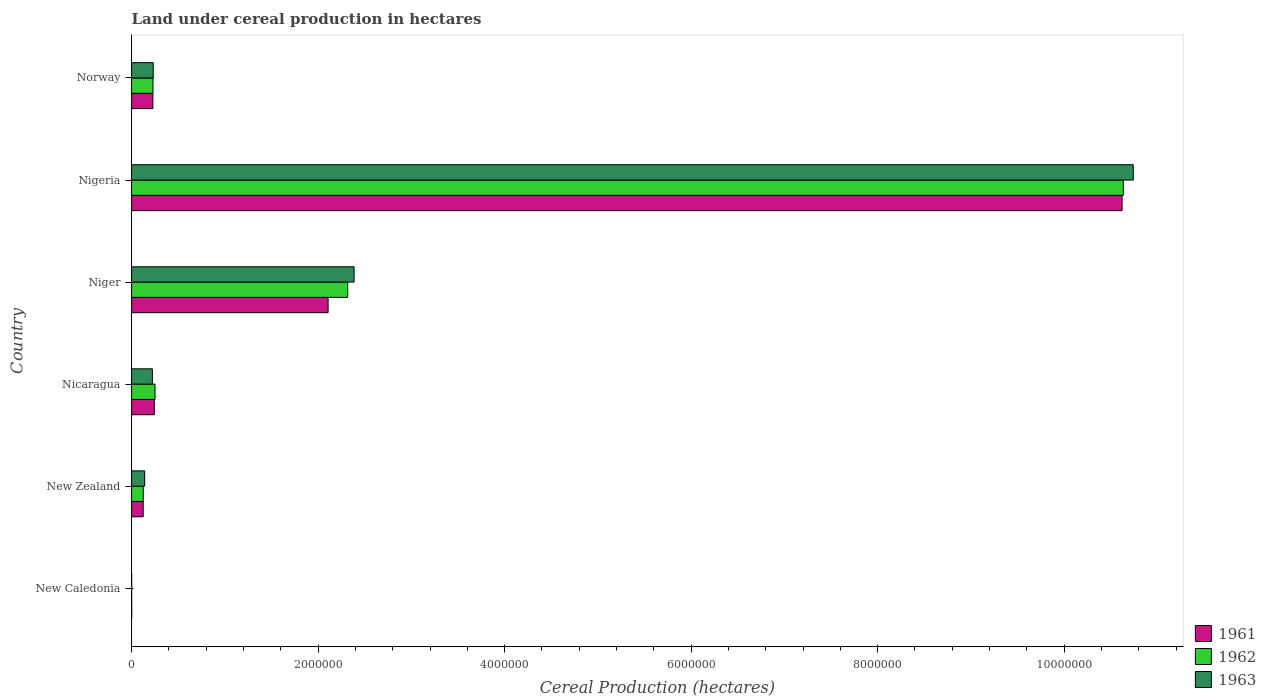How many groups of bars are there?
Provide a succinct answer. 6. How many bars are there on the 1st tick from the bottom?
Keep it short and to the point. 3. What is the label of the 3rd group of bars from the top?
Offer a very short reply. Niger. What is the land under cereal production in 1962 in New Caledonia?
Give a very brief answer. 950. Across all countries, what is the maximum land under cereal production in 1963?
Offer a terse response. 1.07e+07. Across all countries, what is the minimum land under cereal production in 1962?
Your answer should be very brief. 950. In which country was the land under cereal production in 1962 maximum?
Ensure brevity in your answer.  Nigeria. In which country was the land under cereal production in 1962 minimum?
Make the answer very short. New Caledonia. What is the total land under cereal production in 1963 in the graph?
Offer a terse response. 1.37e+07. What is the difference between the land under cereal production in 1962 in Nicaragua and that in Niger?
Provide a succinct answer. -2.07e+06. What is the difference between the land under cereal production in 1963 in Norway and the land under cereal production in 1961 in New Caledonia?
Your answer should be compact. 2.31e+05. What is the average land under cereal production in 1963 per country?
Your answer should be compact. 2.29e+06. What is the ratio of the land under cereal production in 1963 in New Zealand to that in Nigeria?
Offer a terse response. 0.01. Is the land under cereal production in 1962 in New Zealand less than that in Niger?
Offer a terse response. Yes. What is the difference between the highest and the second highest land under cereal production in 1962?
Offer a terse response. 8.32e+06. What is the difference between the highest and the lowest land under cereal production in 1962?
Offer a terse response. 1.06e+07. Is the sum of the land under cereal production in 1962 in New Zealand and Nigeria greater than the maximum land under cereal production in 1963 across all countries?
Your answer should be compact. Yes. Is it the case that in every country, the sum of the land under cereal production in 1963 and land under cereal production in 1962 is greater than the land under cereal production in 1961?
Ensure brevity in your answer.  Yes. How many bars are there?
Ensure brevity in your answer.  18. Are the values on the major ticks of X-axis written in scientific E-notation?
Your answer should be very brief. No. Does the graph contain grids?
Provide a succinct answer. No. Where does the legend appear in the graph?
Offer a very short reply. Bottom right. What is the title of the graph?
Give a very brief answer. Land under cereal production in hectares. What is the label or title of the X-axis?
Your answer should be compact. Cereal Production (hectares). What is the label or title of the Y-axis?
Provide a short and direct response. Country. What is the Cereal Production (hectares) of 1961 in New Caledonia?
Provide a short and direct response. 1050. What is the Cereal Production (hectares) of 1962 in New Caledonia?
Your response must be concise. 950. What is the Cereal Production (hectares) in 1963 in New Caledonia?
Your answer should be very brief. 900. What is the Cereal Production (hectares) in 1961 in New Zealand?
Offer a very short reply. 1.24e+05. What is the Cereal Production (hectares) in 1962 in New Zealand?
Your answer should be compact. 1.26e+05. What is the Cereal Production (hectares) in 1963 in New Zealand?
Ensure brevity in your answer.  1.40e+05. What is the Cereal Production (hectares) of 1961 in Nicaragua?
Give a very brief answer. 2.44e+05. What is the Cereal Production (hectares) of 1962 in Nicaragua?
Make the answer very short. 2.52e+05. What is the Cereal Production (hectares) of 1963 in Nicaragua?
Make the answer very short. 2.23e+05. What is the Cereal Production (hectares) of 1961 in Niger?
Offer a very short reply. 2.11e+06. What is the Cereal Production (hectares) of 1962 in Niger?
Keep it short and to the point. 2.32e+06. What is the Cereal Production (hectares) of 1963 in Niger?
Offer a very short reply. 2.39e+06. What is the Cereal Production (hectares) in 1961 in Nigeria?
Provide a succinct answer. 1.06e+07. What is the Cereal Production (hectares) of 1962 in Nigeria?
Provide a succinct answer. 1.06e+07. What is the Cereal Production (hectares) of 1963 in Nigeria?
Ensure brevity in your answer.  1.07e+07. What is the Cereal Production (hectares) of 1961 in Norway?
Your answer should be compact. 2.28e+05. What is the Cereal Production (hectares) of 1962 in Norway?
Offer a terse response. 2.30e+05. What is the Cereal Production (hectares) in 1963 in Norway?
Ensure brevity in your answer.  2.32e+05. Across all countries, what is the maximum Cereal Production (hectares) in 1961?
Keep it short and to the point. 1.06e+07. Across all countries, what is the maximum Cereal Production (hectares) of 1962?
Your answer should be very brief. 1.06e+07. Across all countries, what is the maximum Cereal Production (hectares) in 1963?
Offer a terse response. 1.07e+07. Across all countries, what is the minimum Cereal Production (hectares) in 1961?
Your answer should be compact. 1050. Across all countries, what is the minimum Cereal Production (hectares) of 1962?
Your response must be concise. 950. Across all countries, what is the minimum Cereal Production (hectares) of 1963?
Make the answer very short. 900. What is the total Cereal Production (hectares) in 1961 in the graph?
Your response must be concise. 1.33e+07. What is the total Cereal Production (hectares) in 1962 in the graph?
Your answer should be compact. 1.36e+07. What is the total Cereal Production (hectares) of 1963 in the graph?
Offer a terse response. 1.37e+07. What is the difference between the Cereal Production (hectares) in 1961 in New Caledonia and that in New Zealand?
Your answer should be compact. -1.23e+05. What is the difference between the Cereal Production (hectares) of 1962 in New Caledonia and that in New Zealand?
Provide a succinct answer. -1.25e+05. What is the difference between the Cereal Production (hectares) in 1963 in New Caledonia and that in New Zealand?
Give a very brief answer. -1.39e+05. What is the difference between the Cereal Production (hectares) in 1961 in New Caledonia and that in Nicaragua?
Provide a short and direct response. -2.42e+05. What is the difference between the Cereal Production (hectares) of 1962 in New Caledonia and that in Nicaragua?
Your answer should be compact. -2.51e+05. What is the difference between the Cereal Production (hectares) of 1963 in New Caledonia and that in Nicaragua?
Your answer should be very brief. -2.22e+05. What is the difference between the Cereal Production (hectares) of 1961 in New Caledonia and that in Niger?
Make the answer very short. -2.11e+06. What is the difference between the Cereal Production (hectares) of 1962 in New Caledonia and that in Niger?
Your response must be concise. -2.32e+06. What is the difference between the Cereal Production (hectares) of 1963 in New Caledonia and that in Niger?
Your answer should be very brief. -2.39e+06. What is the difference between the Cereal Production (hectares) in 1961 in New Caledonia and that in Nigeria?
Give a very brief answer. -1.06e+07. What is the difference between the Cereal Production (hectares) in 1962 in New Caledonia and that in Nigeria?
Keep it short and to the point. -1.06e+07. What is the difference between the Cereal Production (hectares) of 1963 in New Caledonia and that in Nigeria?
Give a very brief answer. -1.07e+07. What is the difference between the Cereal Production (hectares) of 1961 in New Caledonia and that in Norway?
Your response must be concise. -2.27e+05. What is the difference between the Cereal Production (hectares) in 1962 in New Caledonia and that in Norway?
Offer a very short reply. -2.29e+05. What is the difference between the Cereal Production (hectares) of 1963 in New Caledonia and that in Norway?
Your response must be concise. -2.31e+05. What is the difference between the Cereal Production (hectares) of 1961 in New Zealand and that in Nicaragua?
Give a very brief answer. -1.19e+05. What is the difference between the Cereal Production (hectares) of 1962 in New Zealand and that in Nicaragua?
Make the answer very short. -1.26e+05. What is the difference between the Cereal Production (hectares) of 1963 in New Zealand and that in Nicaragua?
Your answer should be very brief. -8.27e+04. What is the difference between the Cereal Production (hectares) in 1961 in New Zealand and that in Niger?
Your response must be concise. -1.98e+06. What is the difference between the Cereal Production (hectares) of 1962 in New Zealand and that in Niger?
Your answer should be very brief. -2.19e+06. What is the difference between the Cereal Production (hectares) of 1963 in New Zealand and that in Niger?
Provide a short and direct response. -2.25e+06. What is the difference between the Cereal Production (hectares) in 1961 in New Zealand and that in Nigeria?
Keep it short and to the point. -1.05e+07. What is the difference between the Cereal Production (hectares) of 1962 in New Zealand and that in Nigeria?
Offer a very short reply. -1.05e+07. What is the difference between the Cereal Production (hectares) in 1963 in New Zealand and that in Nigeria?
Make the answer very short. -1.06e+07. What is the difference between the Cereal Production (hectares) of 1961 in New Zealand and that in Norway?
Your answer should be very brief. -1.04e+05. What is the difference between the Cereal Production (hectares) in 1962 in New Zealand and that in Norway?
Make the answer very short. -1.04e+05. What is the difference between the Cereal Production (hectares) of 1963 in New Zealand and that in Norway?
Your answer should be compact. -9.19e+04. What is the difference between the Cereal Production (hectares) in 1961 in Nicaragua and that in Niger?
Provide a short and direct response. -1.86e+06. What is the difference between the Cereal Production (hectares) of 1962 in Nicaragua and that in Niger?
Keep it short and to the point. -2.07e+06. What is the difference between the Cereal Production (hectares) of 1963 in Nicaragua and that in Niger?
Your answer should be compact. -2.16e+06. What is the difference between the Cereal Production (hectares) in 1961 in Nicaragua and that in Nigeria?
Your answer should be very brief. -1.04e+07. What is the difference between the Cereal Production (hectares) of 1962 in Nicaragua and that in Nigeria?
Make the answer very short. -1.04e+07. What is the difference between the Cereal Production (hectares) of 1963 in Nicaragua and that in Nigeria?
Your answer should be very brief. -1.05e+07. What is the difference between the Cereal Production (hectares) in 1961 in Nicaragua and that in Norway?
Your answer should be compact. 1.54e+04. What is the difference between the Cereal Production (hectares) in 1962 in Nicaragua and that in Norway?
Give a very brief answer. 2.20e+04. What is the difference between the Cereal Production (hectares) in 1963 in Nicaragua and that in Norway?
Provide a succinct answer. -9143. What is the difference between the Cereal Production (hectares) in 1961 in Niger and that in Nigeria?
Your answer should be very brief. -8.51e+06. What is the difference between the Cereal Production (hectares) in 1962 in Niger and that in Nigeria?
Ensure brevity in your answer.  -8.32e+06. What is the difference between the Cereal Production (hectares) of 1963 in Niger and that in Nigeria?
Your response must be concise. -8.36e+06. What is the difference between the Cereal Production (hectares) in 1961 in Niger and that in Norway?
Provide a short and direct response. 1.88e+06. What is the difference between the Cereal Production (hectares) in 1962 in Niger and that in Norway?
Your answer should be compact. 2.09e+06. What is the difference between the Cereal Production (hectares) in 1963 in Niger and that in Norway?
Your answer should be compact. 2.15e+06. What is the difference between the Cereal Production (hectares) in 1961 in Nigeria and that in Norway?
Your response must be concise. 1.04e+07. What is the difference between the Cereal Production (hectares) in 1962 in Nigeria and that in Norway?
Provide a succinct answer. 1.04e+07. What is the difference between the Cereal Production (hectares) of 1963 in Nigeria and that in Norway?
Offer a terse response. 1.05e+07. What is the difference between the Cereal Production (hectares) in 1961 in New Caledonia and the Cereal Production (hectares) in 1962 in New Zealand?
Offer a terse response. -1.25e+05. What is the difference between the Cereal Production (hectares) of 1961 in New Caledonia and the Cereal Production (hectares) of 1963 in New Zealand?
Make the answer very short. -1.39e+05. What is the difference between the Cereal Production (hectares) of 1962 in New Caledonia and the Cereal Production (hectares) of 1963 in New Zealand?
Your answer should be very brief. -1.39e+05. What is the difference between the Cereal Production (hectares) in 1961 in New Caledonia and the Cereal Production (hectares) in 1962 in Nicaragua?
Provide a succinct answer. -2.50e+05. What is the difference between the Cereal Production (hectares) in 1961 in New Caledonia and the Cereal Production (hectares) in 1963 in Nicaragua?
Your response must be concise. -2.22e+05. What is the difference between the Cereal Production (hectares) in 1962 in New Caledonia and the Cereal Production (hectares) in 1963 in Nicaragua?
Provide a succinct answer. -2.22e+05. What is the difference between the Cereal Production (hectares) in 1961 in New Caledonia and the Cereal Production (hectares) in 1962 in Niger?
Provide a succinct answer. -2.32e+06. What is the difference between the Cereal Production (hectares) of 1961 in New Caledonia and the Cereal Production (hectares) of 1963 in Niger?
Your answer should be compact. -2.38e+06. What is the difference between the Cereal Production (hectares) in 1962 in New Caledonia and the Cereal Production (hectares) in 1963 in Niger?
Offer a terse response. -2.39e+06. What is the difference between the Cereal Production (hectares) of 1961 in New Caledonia and the Cereal Production (hectares) of 1962 in Nigeria?
Offer a very short reply. -1.06e+07. What is the difference between the Cereal Production (hectares) of 1961 in New Caledonia and the Cereal Production (hectares) of 1963 in Nigeria?
Offer a terse response. -1.07e+07. What is the difference between the Cereal Production (hectares) of 1962 in New Caledonia and the Cereal Production (hectares) of 1963 in Nigeria?
Offer a very short reply. -1.07e+07. What is the difference between the Cereal Production (hectares) of 1961 in New Caledonia and the Cereal Production (hectares) of 1962 in Norway?
Offer a terse response. -2.28e+05. What is the difference between the Cereal Production (hectares) in 1961 in New Caledonia and the Cereal Production (hectares) in 1963 in Norway?
Ensure brevity in your answer.  -2.31e+05. What is the difference between the Cereal Production (hectares) of 1962 in New Caledonia and the Cereal Production (hectares) of 1963 in Norway?
Provide a short and direct response. -2.31e+05. What is the difference between the Cereal Production (hectares) in 1961 in New Zealand and the Cereal Production (hectares) in 1962 in Nicaragua?
Your answer should be very brief. -1.27e+05. What is the difference between the Cereal Production (hectares) of 1961 in New Zealand and the Cereal Production (hectares) of 1963 in Nicaragua?
Keep it short and to the point. -9.87e+04. What is the difference between the Cereal Production (hectares) in 1962 in New Zealand and the Cereal Production (hectares) in 1963 in Nicaragua?
Offer a very short reply. -9.75e+04. What is the difference between the Cereal Production (hectares) in 1961 in New Zealand and the Cereal Production (hectares) in 1962 in Niger?
Ensure brevity in your answer.  -2.19e+06. What is the difference between the Cereal Production (hectares) in 1961 in New Zealand and the Cereal Production (hectares) in 1963 in Niger?
Make the answer very short. -2.26e+06. What is the difference between the Cereal Production (hectares) in 1962 in New Zealand and the Cereal Production (hectares) in 1963 in Niger?
Your answer should be compact. -2.26e+06. What is the difference between the Cereal Production (hectares) in 1961 in New Zealand and the Cereal Production (hectares) in 1962 in Nigeria?
Your answer should be very brief. -1.05e+07. What is the difference between the Cereal Production (hectares) in 1961 in New Zealand and the Cereal Production (hectares) in 1963 in Nigeria?
Your answer should be very brief. -1.06e+07. What is the difference between the Cereal Production (hectares) of 1962 in New Zealand and the Cereal Production (hectares) of 1963 in Nigeria?
Your answer should be very brief. -1.06e+07. What is the difference between the Cereal Production (hectares) in 1961 in New Zealand and the Cereal Production (hectares) in 1962 in Norway?
Offer a terse response. -1.05e+05. What is the difference between the Cereal Production (hectares) in 1961 in New Zealand and the Cereal Production (hectares) in 1963 in Norway?
Make the answer very short. -1.08e+05. What is the difference between the Cereal Production (hectares) in 1962 in New Zealand and the Cereal Production (hectares) in 1963 in Norway?
Offer a very short reply. -1.07e+05. What is the difference between the Cereal Production (hectares) of 1961 in Nicaragua and the Cereal Production (hectares) of 1962 in Niger?
Your answer should be very brief. -2.07e+06. What is the difference between the Cereal Production (hectares) of 1961 in Nicaragua and the Cereal Production (hectares) of 1963 in Niger?
Provide a short and direct response. -2.14e+06. What is the difference between the Cereal Production (hectares) in 1962 in Nicaragua and the Cereal Production (hectares) in 1963 in Niger?
Provide a succinct answer. -2.13e+06. What is the difference between the Cereal Production (hectares) of 1961 in Nicaragua and the Cereal Production (hectares) of 1962 in Nigeria?
Your answer should be very brief. -1.04e+07. What is the difference between the Cereal Production (hectares) in 1961 in Nicaragua and the Cereal Production (hectares) in 1963 in Nigeria?
Give a very brief answer. -1.05e+07. What is the difference between the Cereal Production (hectares) in 1962 in Nicaragua and the Cereal Production (hectares) in 1963 in Nigeria?
Offer a very short reply. -1.05e+07. What is the difference between the Cereal Production (hectares) of 1961 in Nicaragua and the Cereal Production (hectares) of 1962 in Norway?
Offer a very short reply. 1.40e+04. What is the difference between the Cereal Production (hectares) of 1961 in Nicaragua and the Cereal Production (hectares) of 1963 in Norway?
Offer a terse response. 1.13e+04. What is the difference between the Cereal Production (hectares) in 1962 in Nicaragua and the Cereal Production (hectares) in 1963 in Norway?
Provide a short and direct response. 1.93e+04. What is the difference between the Cereal Production (hectares) in 1961 in Niger and the Cereal Production (hectares) in 1962 in Nigeria?
Offer a terse response. -8.53e+06. What is the difference between the Cereal Production (hectares) of 1961 in Niger and the Cereal Production (hectares) of 1963 in Nigeria?
Ensure brevity in your answer.  -8.63e+06. What is the difference between the Cereal Production (hectares) in 1962 in Niger and the Cereal Production (hectares) in 1963 in Nigeria?
Make the answer very short. -8.42e+06. What is the difference between the Cereal Production (hectares) in 1961 in Niger and the Cereal Production (hectares) in 1962 in Norway?
Keep it short and to the point. 1.88e+06. What is the difference between the Cereal Production (hectares) in 1961 in Niger and the Cereal Production (hectares) in 1963 in Norway?
Your answer should be compact. 1.87e+06. What is the difference between the Cereal Production (hectares) in 1962 in Niger and the Cereal Production (hectares) in 1963 in Norway?
Give a very brief answer. 2.09e+06. What is the difference between the Cereal Production (hectares) of 1961 in Nigeria and the Cereal Production (hectares) of 1962 in Norway?
Give a very brief answer. 1.04e+07. What is the difference between the Cereal Production (hectares) in 1961 in Nigeria and the Cereal Production (hectares) in 1963 in Norway?
Offer a very short reply. 1.04e+07. What is the difference between the Cereal Production (hectares) in 1962 in Nigeria and the Cereal Production (hectares) in 1963 in Norway?
Your response must be concise. 1.04e+07. What is the average Cereal Production (hectares) in 1961 per country?
Offer a very short reply. 2.22e+06. What is the average Cereal Production (hectares) of 1962 per country?
Your response must be concise. 2.26e+06. What is the average Cereal Production (hectares) of 1963 per country?
Your answer should be compact. 2.29e+06. What is the difference between the Cereal Production (hectares) of 1961 and Cereal Production (hectares) of 1962 in New Caledonia?
Keep it short and to the point. 100. What is the difference between the Cereal Production (hectares) in 1961 and Cereal Production (hectares) in 1963 in New Caledonia?
Keep it short and to the point. 150. What is the difference between the Cereal Production (hectares) in 1961 and Cereal Production (hectares) in 1962 in New Zealand?
Keep it short and to the point. -1208. What is the difference between the Cereal Production (hectares) of 1961 and Cereal Production (hectares) of 1963 in New Zealand?
Your answer should be very brief. -1.60e+04. What is the difference between the Cereal Production (hectares) in 1962 and Cereal Production (hectares) in 1963 in New Zealand?
Your answer should be compact. -1.48e+04. What is the difference between the Cereal Production (hectares) of 1961 and Cereal Production (hectares) of 1962 in Nicaragua?
Your answer should be compact. -8000. What is the difference between the Cereal Production (hectares) of 1961 and Cereal Production (hectares) of 1963 in Nicaragua?
Provide a succinct answer. 2.04e+04. What is the difference between the Cereal Production (hectares) of 1962 and Cereal Production (hectares) of 1963 in Nicaragua?
Give a very brief answer. 2.84e+04. What is the difference between the Cereal Production (hectares) in 1961 and Cereal Production (hectares) in 1962 in Niger?
Give a very brief answer. -2.10e+05. What is the difference between the Cereal Production (hectares) of 1961 and Cereal Production (hectares) of 1963 in Niger?
Provide a succinct answer. -2.79e+05. What is the difference between the Cereal Production (hectares) in 1962 and Cereal Production (hectares) in 1963 in Niger?
Give a very brief answer. -6.85e+04. What is the difference between the Cereal Production (hectares) in 1961 and Cereal Production (hectares) in 1962 in Nigeria?
Offer a terse response. -1.30e+04. What is the difference between the Cereal Production (hectares) in 1961 and Cereal Production (hectares) in 1963 in Nigeria?
Your answer should be compact. -1.20e+05. What is the difference between the Cereal Production (hectares) of 1962 and Cereal Production (hectares) of 1963 in Nigeria?
Ensure brevity in your answer.  -1.07e+05. What is the difference between the Cereal Production (hectares) in 1961 and Cereal Production (hectares) in 1962 in Norway?
Your response must be concise. -1405. What is the difference between the Cereal Production (hectares) in 1961 and Cereal Production (hectares) in 1963 in Norway?
Provide a succinct answer. -4126. What is the difference between the Cereal Production (hectares) in 1962 and Cereal Production (hectares) in 1963 in Norway?
Give a very brief answer. -2721. What is the ratio of the Cereal Production (hectares) of 1961 in New Caledonia to that in New Zealand?
Provide a short and direct response. 0.01. What is the ratio of the Cereal Production (hectares) in 1962 in New Caledonia to that in New Zealand?
Keep it short and to the point. 0.01. What is the ratio of the Cereal Production (hectares) in 1963 in New Caledonia to that in New Zealand?
Provide a short and direct response. 0.01. What is the ratio of the Cereal Production (hectares) in 1961 in New Caledonia to that in Nicaragua?
Give a very brief answer. 0. What is the ratio of the Cereal Production (hectares) of 1962 in New Caledonia to that in Nicaragua?
Keep it short and to the point. 0. What is the ratio of the Cereal Production (hectares) of 1963 in New Caledonia to that in Nicaragua?
Ensure brevity in your answer.  0. What is the ratio of the Cereal Production (hectares) of 1961 in New Caledonia to that in Niger?
Provide a short and direct response. 0. What is the ratio of the Cereal Production (hectares) of 1963 in New Caledonia to that in Niger?
Provide a short and direct response. 0. What is the ratio of the Cereal Production (hectares) in 1961 in New Caledonia to that in Nigeria?
Provide a short and direct response. 0. What is the ratio of the Cereal Production (hectares) in 1961 in New Caledonia to that in Norway?
Keep it short and to the point. 0. What is the ratio of the Cereal Production (hectares) in 1962 in New Caledonia to that in Norway?
Make the answer very short. 0. What is the ratio of the Cereal Production (hectares) of 1963 in New Caledonia to that in Norway?
Provide a succinct answer. 0. What is the ratio of the Cereal Production (hectares) of 1961 in New Zealand to that in Nicaragua?
Make the answer very short. 0.51. What is the ratio of the Cereal Production (hectares) in 1962 in New Zealand to that in Nicaragua?
Offer a very short reply. 0.5. What is the ratio of the Cereal Production (hectares) of 1963 in New Zealand to that in Nicaragua?
Ensure brevity in your answer.  0.63. What is the ratio of the Cereal Production (hectares) of 1961 in New Zealand to that in Niger?
Your response must be concise. 0.06. What is the ratio of the Cereal Production (hectares) of 1962 in New Zealand to that in Niger?
Ensure brevity in your answer.  0.05. What is the ratio of the Cereal Production (hectares) of 1963 in New Zealand to that in Niger?
Offer a terse response. 0.06. What is the ratio of the Cereal Production (hectares) of 1961 in New Zealand to that in Nigeria?
Ensure brevity in your answer.  0.01. What is the ratio of the Cereal Production (hectares) of 1962 in New Zealand to that in Nigeria?
Ensure brevity in your answer.  0.01. What is the ratio of the Cereal Production (hectares) in 1963 in New Zealand to that in Nigeria?
Keep it short and to the point. 0.01. What is the ratio of the Cereal Production (hectares) of 1961 in New Zealand to that in Norway?
Offer a very short reply. 0.55. What is the ratio of the Cereal Production (hectares) of 1962 in New Zealand to that in Norway?
Offer a very short reply. 0.55. What is the ratio of the Cereal Production (hectares) in 1963 in New Zealand to that in Norway?
Keep it short and to the point. 0.6. What is the ratio of the Cereal Production (hectares) of 1961 in Nicaragua to that in Niger?
Keep it short and to the point. 0.12. What is the ratio of the Cereal Production (hectares) of 1962 in Nicaragua to that in Niger?
Offer a terse response. 0.11. What is the ratio of the Cereal Production (hectares) of 1963 in Nicaragua to that in Niger?
Your answer should be very brief. 0.09. What is the ratio of the Cereal Production (hectares) of 1961 in Nicaragua to that in Nigeria?
Your response must be concise. 0.02. What is the ratio of the Cereal Production (hectares) in 1962 in Nicaragua to that in Nigeria?
Your answer should be very brief. 0.02. What is the ratio of the Cereal Production (hectares) in 1963 in Nicaragua to that in Nigeria?
Give a very brief answer. 0.02. What is the ratio of the Cereal Production (hectares) in 1961 in Nicaragua to that in Norway?
Offer a terse response. 1.07. What is the ratio of the Cereal Production (hectares) in 1962 in Nicaragua to that in Norway?
Make the answer very short. 1.1. What is the ratio of the Cereal Production (hectares) in 1963 in Nicaragua to that in Norway?
Give a very brief answer. 0.96. What is the ratio of the Cereal Production (hectares) in 1961 in Niger to that in Nigeria?
Provide a succinct answer. 0.2. What is the ratio of the Cereal Production (hectares) of 1962 in Niger to that in Nigeria?
Give a very brief answer. 0.22. What is the ratio of the Cereal Production (hectares) of 1963 in Niger to that in Nigeria?
Provide a succinct answer. 0.22. What is the ratio of the Cereal Production (hectares) in 1961 in Niger to that in Norway?
Offer a terse response. 9.24. What is the ratio of the Cereal Production (hectares) of 1962 in Niger to that in Norway?
Offer a very short reply. 10.1. What is the ratio of the Cereal Production (hectares) of 1963 in Niger to that in Norway?
Your answer should be compact. 10.27. What is the ratio of the Cereal Production (hectares) of 1961 in Nigeria to that in Norway?
Ensure brevity in your answer.  46.56. What is the ratio of the Cereal Production (hectares) of 1962 in Nigeria to that in Norway?
Your response must be concise. 46.33. What is the ratio of the Cereal Production (hectares) in 1963 in Nigeria to that in Norway?
Make the answer very short. 46.25. What is the difference between the highest and the second highest Cereal Production (hectares) of 1961?
Provide a short and direct response. 8.51e+06. What is the difference between the highest and the second highest Cereal Production (hectares) in 1962?
Your answer should be very brief. 8.32e+06. What is the difference between the highest and the second highest Cereal Production (hectares) of 1963?
Your response must be concise. 8.36e+06. What is the difference between the highest and the lowest Cereal Production (hectares) of 1961?
Offer a terse response. 1.06e+07. What is the difference between the highest and the lowest Cereal Production (hectares) in 1962?
Your answer should be very brief. 1.06e+07. What is the difference between the highest and the lowest Cereal Production (hectares) in 1963?
Ensure brevity in your answer.  1.07e+07. 